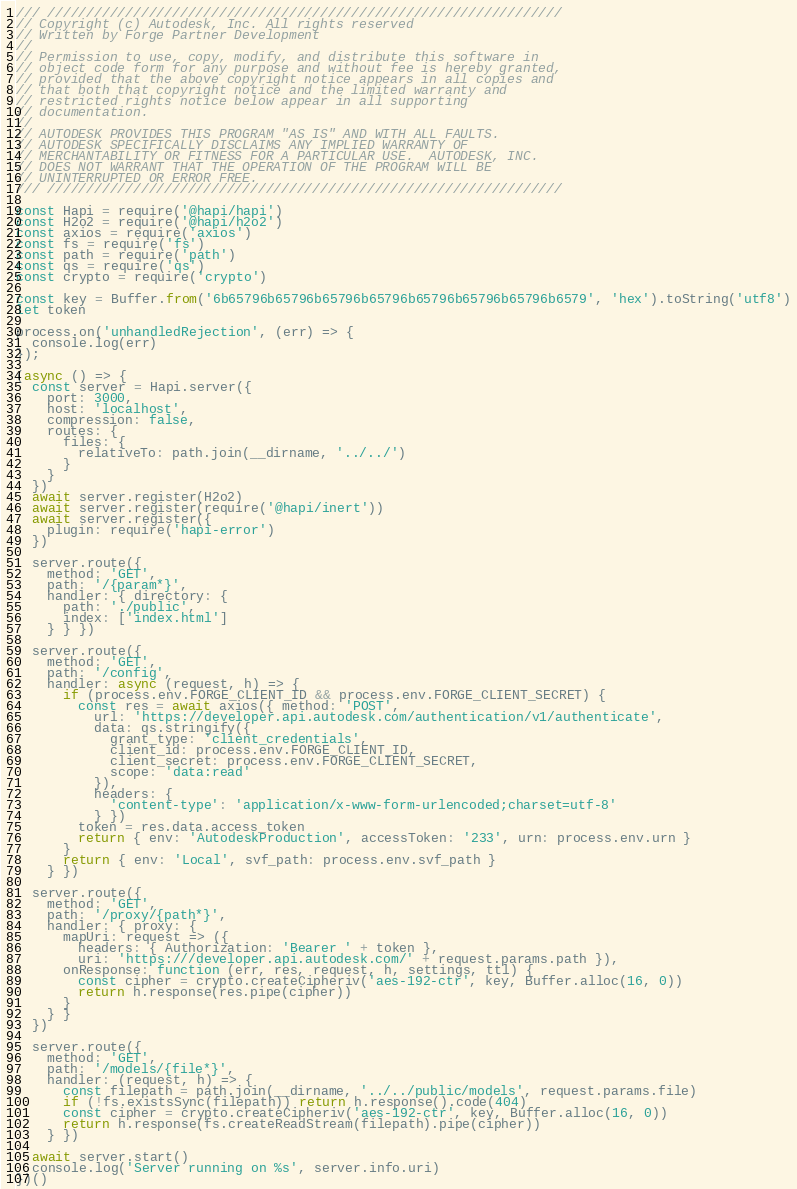Convert code to text. <code><loc_0><loc_0><loc_500><loc_500><_JavaScript_>/// //////////////////////////////////////////////////////////////////
// Copyright (c) Autodesk, Inc. All rights reserved
// Written by Forge Partner Development
//
// Permission to use, copy, modify, and distribute this software in
// object code form for any purpose and without fee is hereby granted,
// provided that the above copyright notice appears in all copies and
// that both that copyright notice and the limited warranty and
// restricted rights notice below appear in all supporting
// documentation.
//
// AUTODESK PROVIDES THIS PROGRAM "AS IS" AND WITH ALL FAULTS.
// AUTODESK SPECIFICALLY DISCLAIMS ANY IMPLIED WARRANTY OF
// MERCHANTABILITY OR FITNESS FOR A PARTICULAR USE.  AUTODESK, INC.
// DOES NOT WARRANT THAT THE OPERATION OF THE PROGRAM WILL BE
// UNINTERRUPTED OR ERROR FREE.
/// //////////////////////////////////////////////////////////////////

const Hapi = require('@hapi/hapi')
const H2o2 = require('@hapi/h2o2')
const axios = require('axios')
const fs = require('fs')
const path = require('path')
const qs = require('qs')
const crypto = require('crypto')

const key = Buffer.from('6b65796b65796b65796b65796b65796b65796b65796b6579', 'hex').toString('utf8')
let token

process.on('unhandledRejection', (err) => {
  console.log(err)
});

(async () => {
  const server = Hapi.server({
    port: 3000,
    host: 'localhost',
    compression: false,
    routes: {
      files: {
        relativeTo: path.join(__dirname, '../../')
      }
    }
  })
  await server.register(H2o2)
  await server.register(require('@hapi/inert'))
  await server.register({
    plugin: require('hapi-error')
  })

  server.route({
    method: 'GET',
    path: '/{param*}',
    handler: { directory: {
      path: './public',
      index: ['index.html']
    } } })

  server.route({
    method: 'GET',
    path: '/config',
    handler: async (request, h) => {
      if (process.env.FORGE_CLIENT_ID && process.env.FORGE_CLIENT_SECRET) {
        const res = await axios({ method: 'POST',
          url: 'https://developer.api.autodesk.com/authentication/v1/authenticate',
          data: qs.stringify({
            grant_type: 'client_credentials',
            client_id: process.env.FORGE_CLIENT_ID,
            client_secret: process.env.FORGE_CLIENT_SECRET,
            scope: 'data:read'
          }),
          headers: {
            'content-type': 'application/x-www-form-urlencoded;charset=utf-8'
          } })
        token = res.data.access_token
        return { env: 'AutodeskProduction', accessToken: '233', urn: process.env.urn }
      }
      return { env: 'Local', svf_path: process.env.svf_path }
    } })

  server.route({
    method: 'GET',
    path: '/proxy/{path*}',
    handler: { proxy: {
      mapUri: request => ({
        headers: { Authorization: 'Bearer ' + token },
        uri: 'https:///developer.api.autodesk.com/' + request.params.path }),
      onResponse: function (err, res, request, h, settings, ttl) {
        const cipher = crypto.createCipheriv('aes-192-ctr', key, Buffer.alloc(16, 0))
        return h.response(res.pipe(cipher))
      }
    } }
  })

  server.route({
    method: 'GET',
    path: '/models/{file*}',
    handler: (request, h) => {
      const filepath = path.join(__dirname, '../../public/models', request.params.file)
      if (!fs.existsSync(filepath)) return h.response().code(404)
      const cipher = crypto.createCipheriv('aes-192-ctr', key, Buffer.alloc(16, 0))
      return h.response(fs.createReadStream(filepath).pipe(cipher))
    } })

  await server.start()
  console.log('Server running on %s', server.info.uri)
})()
</code> 